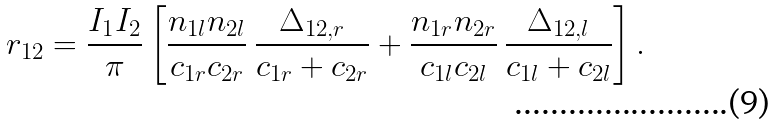Convert formula to latex. <formula><loc_0><loc_0><loc_500><loc_500>r _ { 1 2 } = \frac { I _ { 1 } I _ { 2 } } { \pi } \left [ \frac { n _ { 1 l } n _ { 2 l } } { c _ { 1 r } c _ { 2 r } } \, \frac { \Delta _ { 1 2 , r } } { c _ { 1 r } + c _ { 2 r } } + \frac { n _ { 1 r } n _ { 2 r } } { c _ { 1 l } c _ { 2 l } } \, \frac { \Delta _ { 1 2 , l } } { c _ { 1 l } + c _ { 2 l } } \right ] .</formula> 